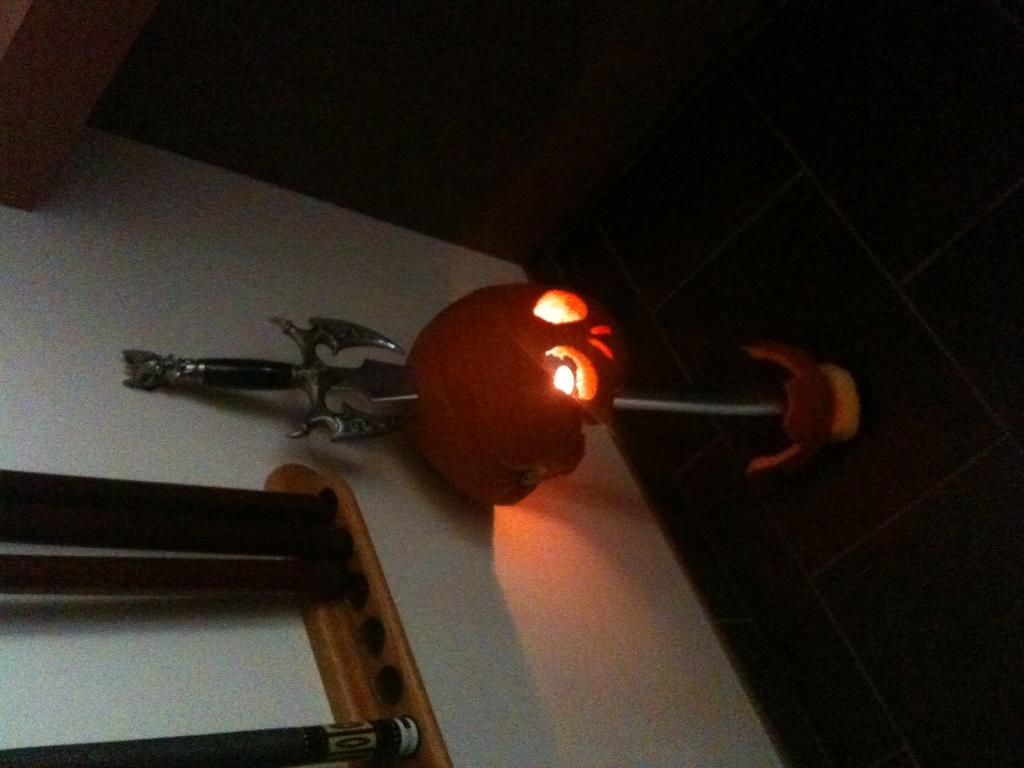What can be seen in the image that provides illumination? There are lights in the image. What type of object is present that could be used for defense or offense? There is a weapon in the image. What type of objects can be seen in the background of the image? There are wooden objects in the background of the image. What color is the wall in the image? The wall is white in color. What type of farm animals can be seen in the image? There are no farm animals present in the image. What base theory is being discussed in the image? There is no discussion of a base theory in the image. 